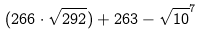<formula> <loc_0><loc_0><loc_500><loc_500>( 2 6 6 \cdot \sqrt { 2 9 2 } ) + 2 6 3 - \sqrt { 1 0 } ^ { 7 }</formula> 